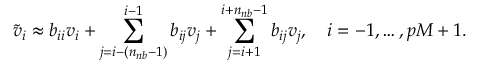Convert formula to latex. <formula><loc_0><loc_0><loc_500><loc_500>\widetilde { v } _ { i } \approx b _ { i i } v _ { i } + \sum _ { j = i - ( n _ { n b } - 1 ) } ^ { i - 1 } b _ { i j } v _ { j } + \sum _ { j = i + 1 } ^ { i + n _ { n b } - 1 } b _ { i j } v _ { j } , \quad i = - 1 , \dots , p M + 1 .</formula> 